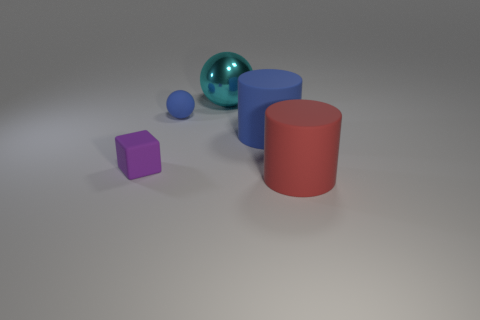Add 5 tiny cubes. How many objects exist? 10 Add 2 large blue matte objects. How many large blue matte objects are left? 3 Add 4 large gray rubber balls. How many large gray rubber balls exist? 4 Subtract 0 gray spheres. How many objects are left? 5 Subtract all blocks. How many objects are left? 4 Subtract all big rubber objects. Subtract all blue cylinders. How many objects are left? 2 